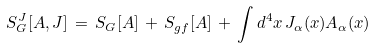Convert formula to latex. <formula><loc_0><loc_0><loc_500><loc_500>S _ { G } ^ { J } [ A , J ] \, = \, S _ { G } [ A ] \, + \, S _ { g f } [ A ] \, + \, \int d ^ { 4 } x \, J _ { \alpha } ( x ) A _ { \alpha } ( x ) \,</formula> 